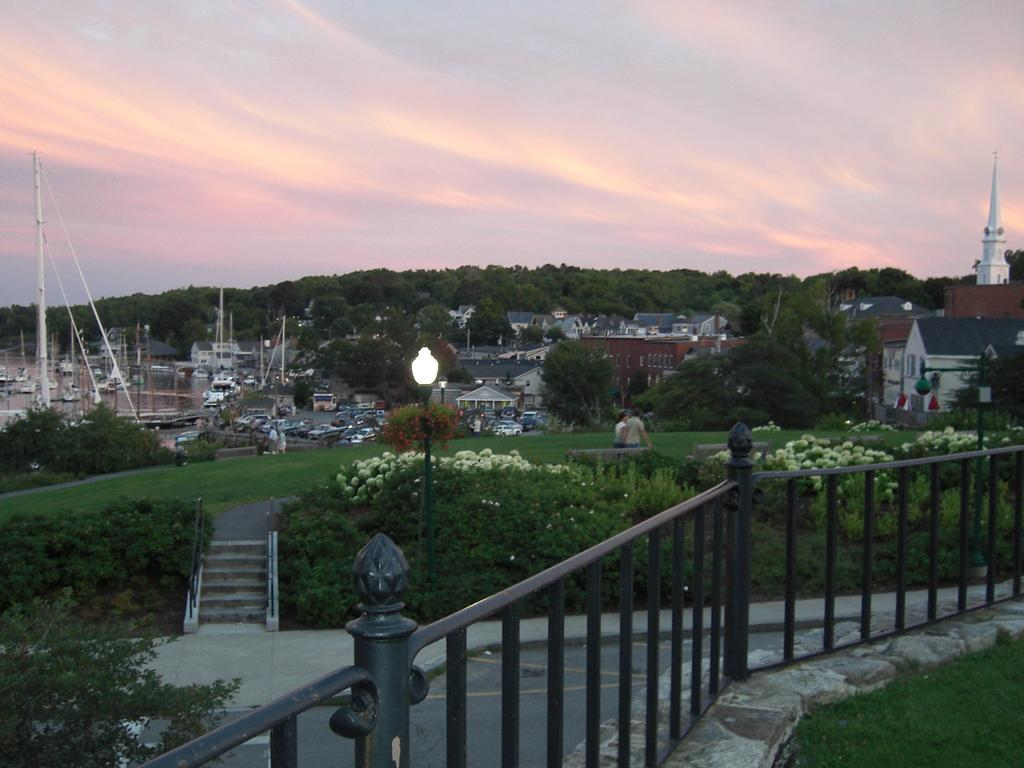What type of outdoor space is shown in the image? The image depicts a garden. What types of vegetation can be seen in the garden? There are trees, flowers, and plants in the garden. Are there any structures or objects in the garden? Yes, there is a lamp pole in the garden. What time of day is it in the image, and how does the representative feel about the morning? The image does not provide information about the time of day or any representative's feelings. The image only shows a garden with trees, flowers, plants, and a lamp pole. 